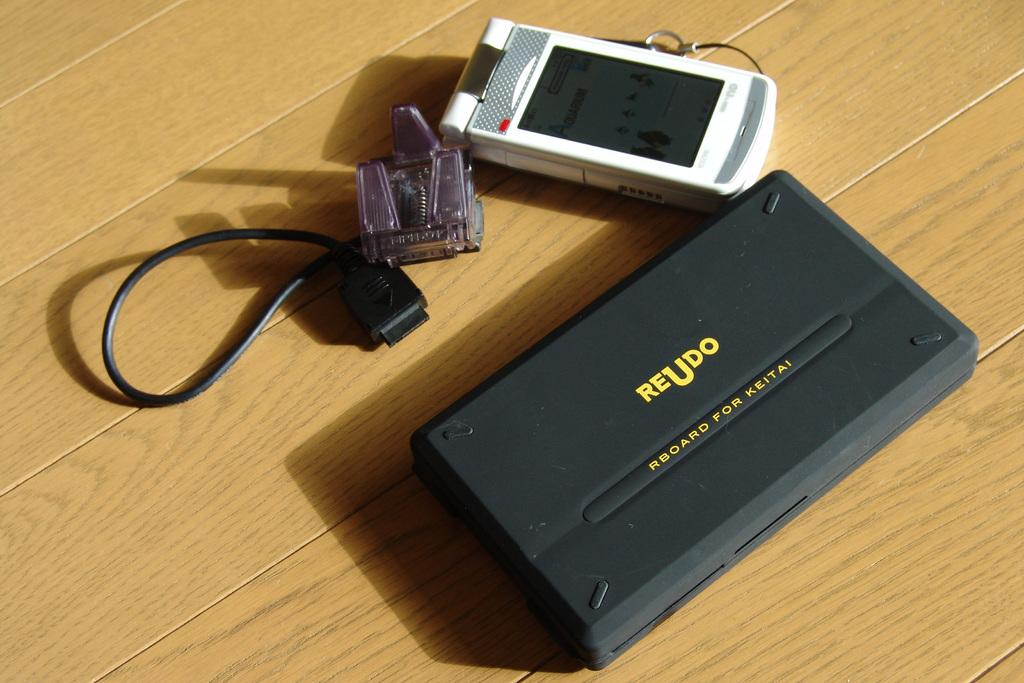<image>
Offer a succinct explanation of the picture presented. a black and yellow reudo item on the ground 